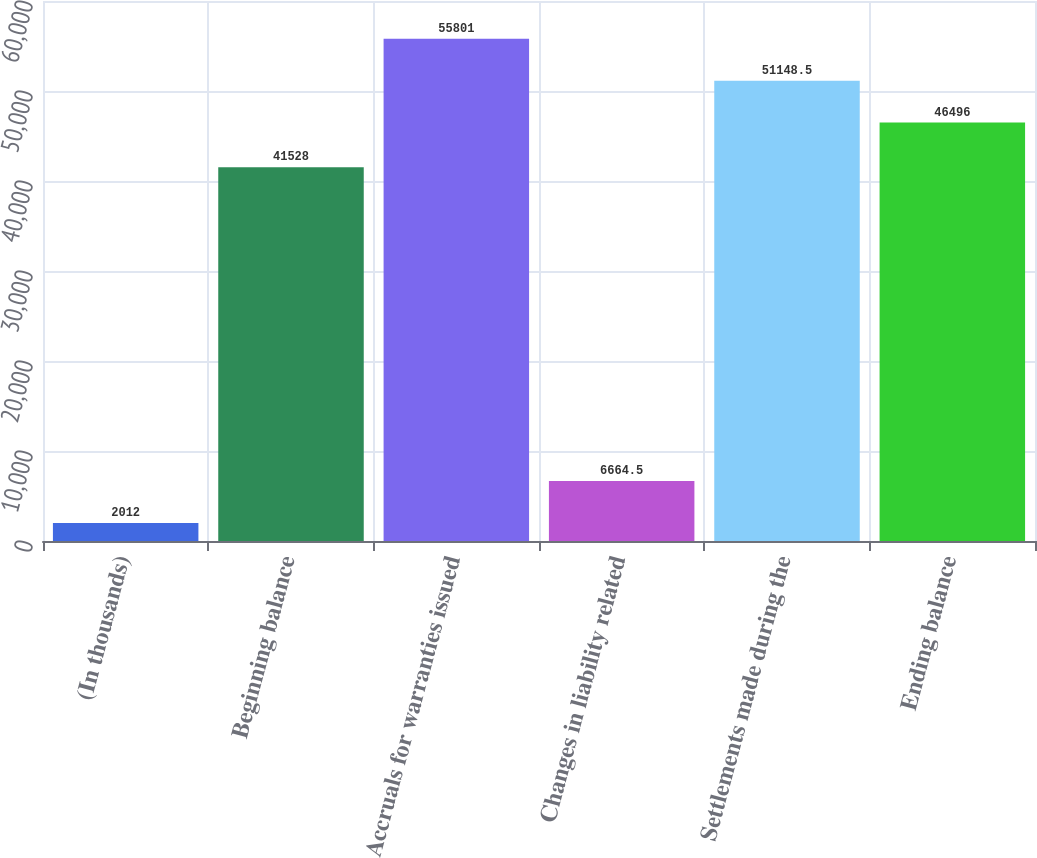Convert chart. <chart><loc_0><loc_0><loc_500><loc_500><bar_chart><fcel>(In thousands)<fcel>Beginning balance<fcel>Accruals for warranties issued<fcel>Changes in liability related<fcel>Settlements made during the<fcel>Ending balance<nl><fcel>2012<fcel>41528<fcel>55801<fcel>6664.5<fcel>51148.5<fcel>46496<nl></chart> 